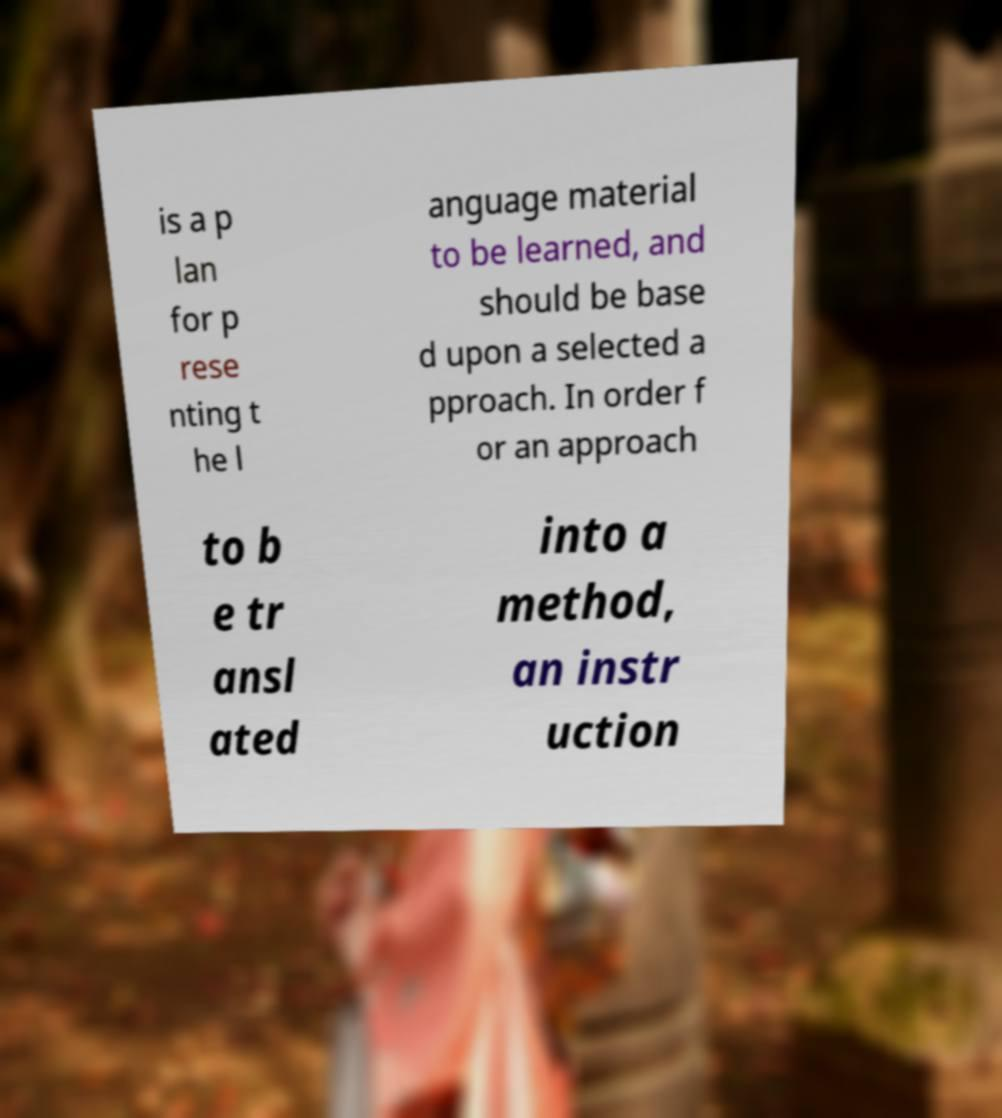Please identify and transcribe the text found in this image. is a p lan for p rese nting t he l anguage material to be learned, and should be base d upon a selected a pproach. In order f or an approach to b e tr ansl ated into a method, an instr uction 